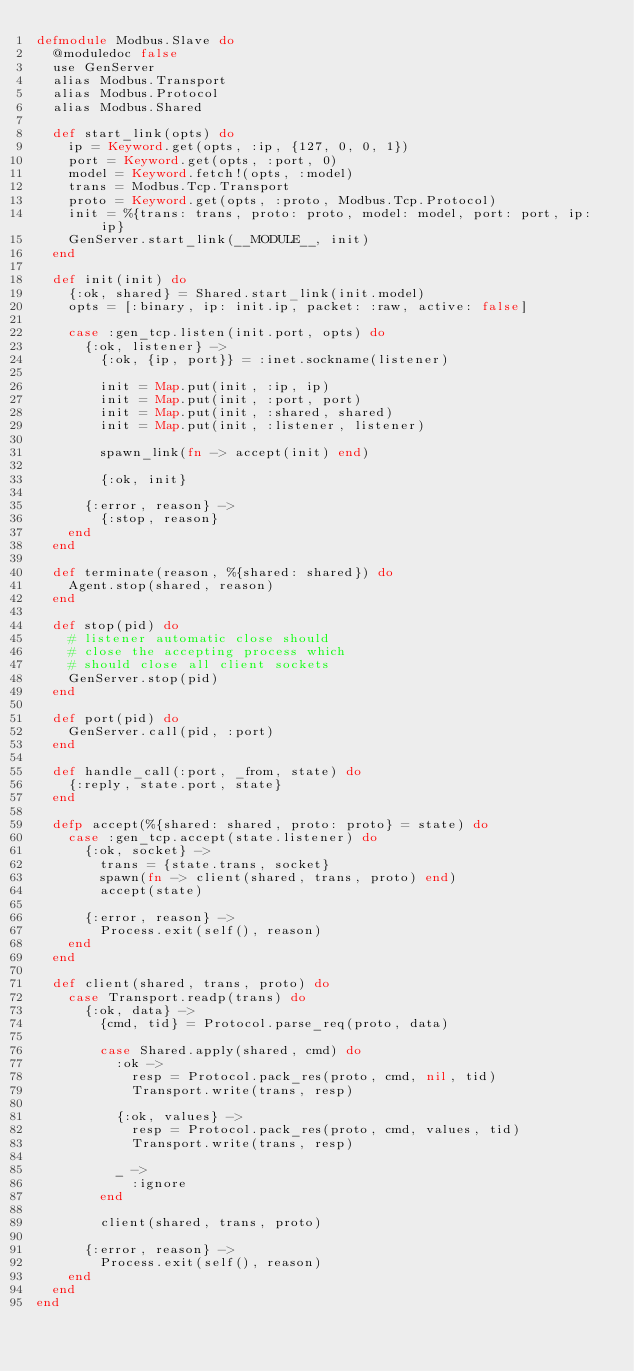<code> <loc_0><loc_0><loc_500><loc_500><_Elixir_>defmodule Modbus.Slave do
  @moduledoc false
  use GenServer
  alias Modbus.Transport
  alias Modbus.Protocol
  alias Modbus.Shared

  def start_link(opts) do
    ip = Keyword.get(opts, :ip, {127, 0, 0, 1})
    port = Keyword.get(opts, :port, 0)
    model = Keyword.fetch!(opts, :model)
    trans = Modbus.Tcp.Transport
    proto = Keyword.get(opts, :proto, Modbus.Tcp.Protocol)
    init = %{trans: trans, proto: proto, model: model, port: port, ip: ip}
    GenServer.start_link(__MODULE__, init)
  end

  def init(init) do
    {:ok, shared} = Shared.start_link(init.model)
    opts = [:binary, ip: init.ip, packet: :raw, active: false]

    case :gen_tcp.listen(init.port, opts) do
      {:ok, listener} ->
        {:ok, {ip, port}} = :inet.sockname(listener)

        init = Map.put(init, :ip, ip)
        init = Map.put(init, :port, port)
        init = Map.put(init, :shared, shared)
        init = Map.put(init, :listener, listener)

        spawn_link(fn -> accept(init) end)

        {:ok, init}

      {:error, reason} ->
        {:stop, reason}
    end
  end

  def terminate(reason, %{shared: shared}) do
    Agent.stop(shared, reason)
  end

  def stop(pid) do
    # listener automatic close should
    # close the accepting process which
    # should close all client sockets
    GenServer.stop(pid)
  end

  def port(pid) do
    GenServer.call(pid, :port)
  end

  def handle_call(:port, _from, state) do
    {:reply, state.port, state}
  end

  defp accept(%{shared: shared, proto: proto} = state) do
    case :gen_tcp.accept(state.listener) do
      {:ok, socket} ->
        trans = {state.trans, socket}
        spawn(fn -> client(shared, trans, proto) end)
        accept(state)

      {:error, reason} ->
        Process.exit(self(), reason)
    end
  end

  def client(shared, trans, proto) do
    case Transport.readp(trans) do
      {:ok, data} ->
        {cmd, tid} = Protocol.parse_req(proto, data)

        case Shared.apply(shared, cmd) do
          :ok ->
            resp = Protocol.pack_res(proto, cmd, nil, tid)
            Transport.write(trans, resp)

          {:ok, values} ->
            resp = Protocol.pack_res(proto, cmd, values, tid)
            Transport.write(trans, resp)

          _ ->
            :ignore
        end

        client(shared, trans, proto)

      {:error, reason} ->
        Process.exit(self(), reason)
    end
  end
end
</code> 